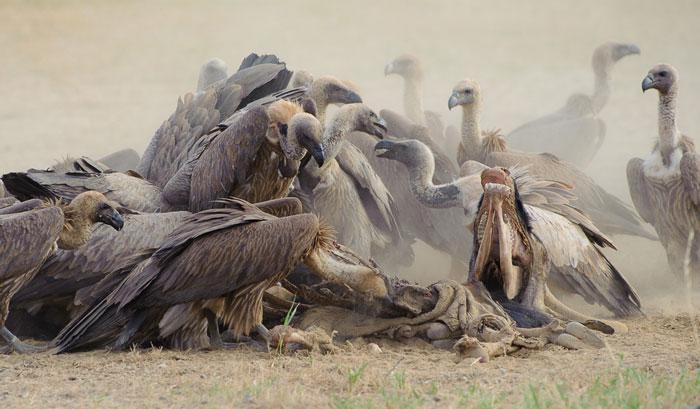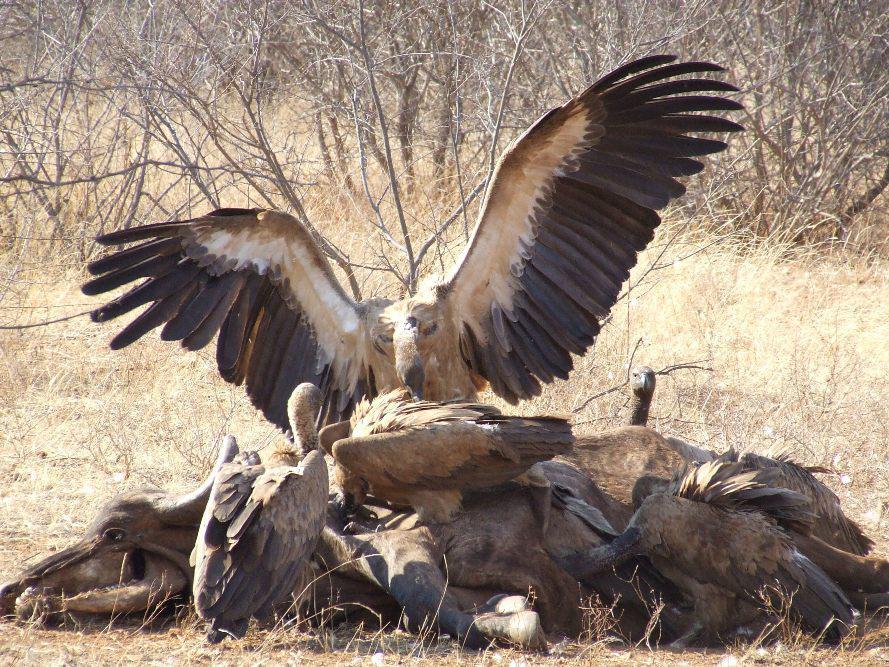The first image is the image on the left, the second image is the image on the right. Assess this claim about the two images: "Vultures ripping flesh off of bones can be seen in one image.". Correct or not? Answer yes or no. No. The first image is the image on the left, the second image is the image on the right. Evaluate the accuracy of this statement regarding the images: "At the center of the image there are at least two vultures picking over the carcass of a deceased animal.". Is it true? Answer yes or no. Yes. 